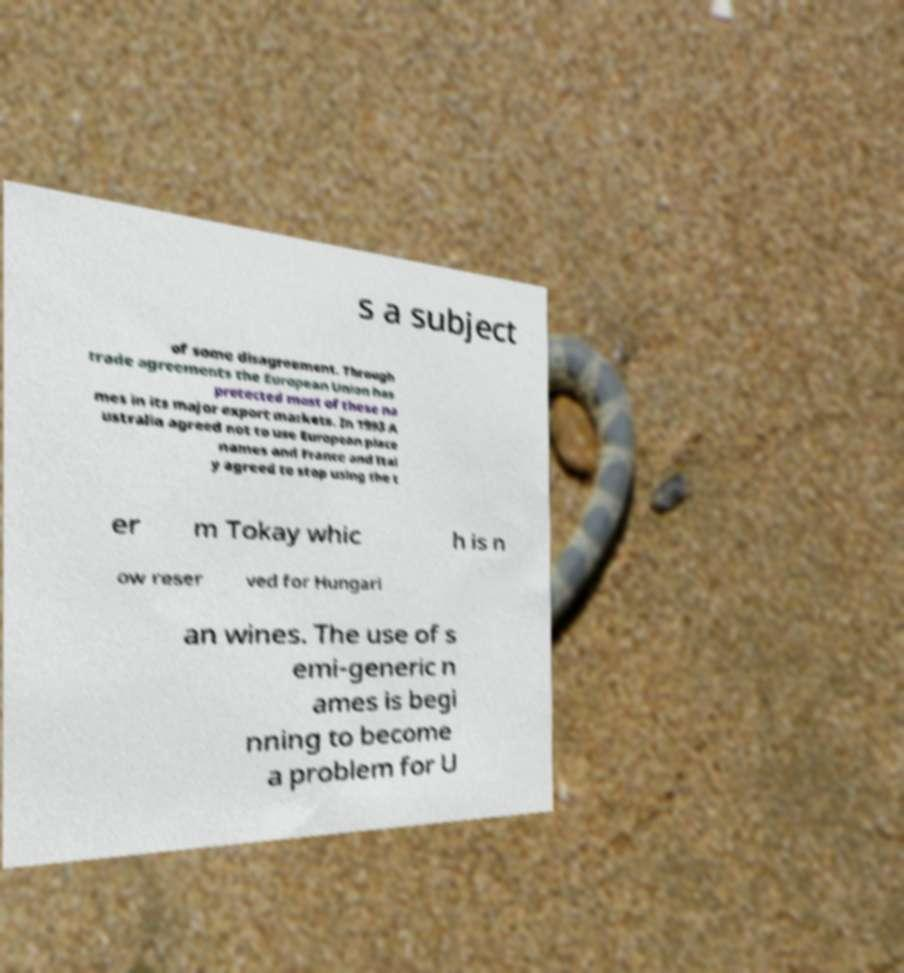Could you extract and type out the text from this image? s a subject of some disagreement. Through trade agreements the European Union has protected most of these na mes in its major export markets. In 1993 A ustralia agreed not to use European place names and France and Ital y agreed to stop using the t er m Tokay whic h is n ow reser ved for Hungari an wines. The use of s emi-generic n ames is begi nning to become a problem for U 